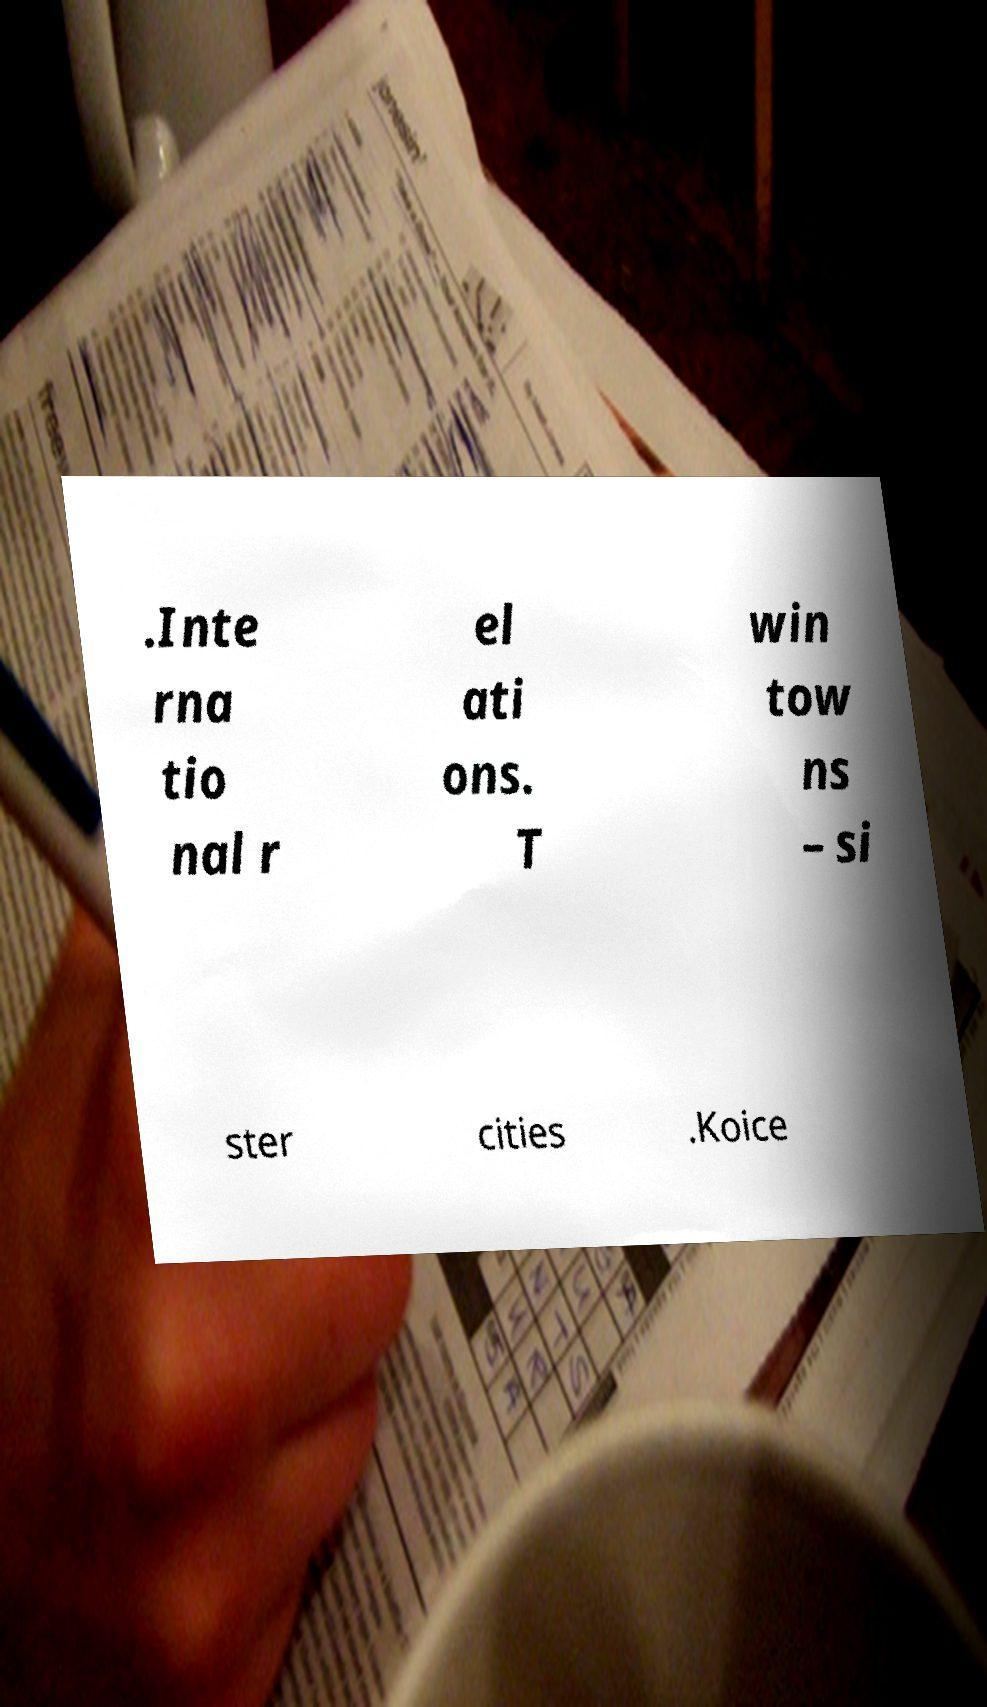Please identify and transcribe the text found in this image. .Inte rna tio nal r el ati ons. T win tow ns – si ster cities .Koice 